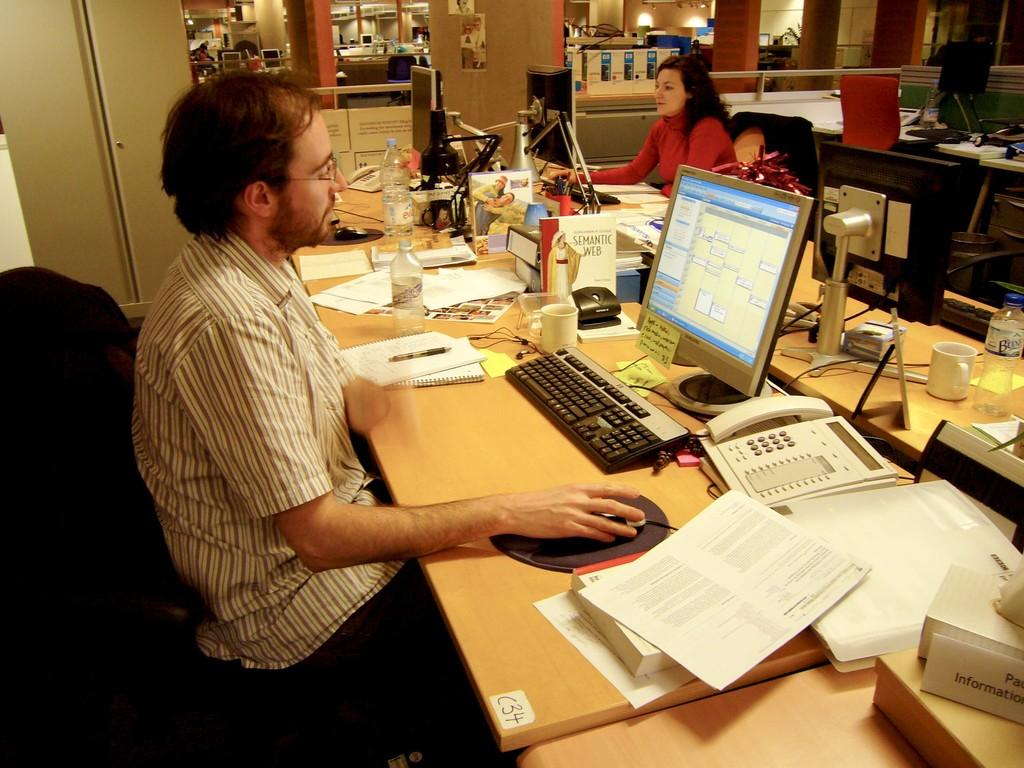<image>
Relay a brief, clear account of the picture shown. A man sitting at a messy desk on the bottom right corner of the pic is a piece of paper that says Pa... Information. 